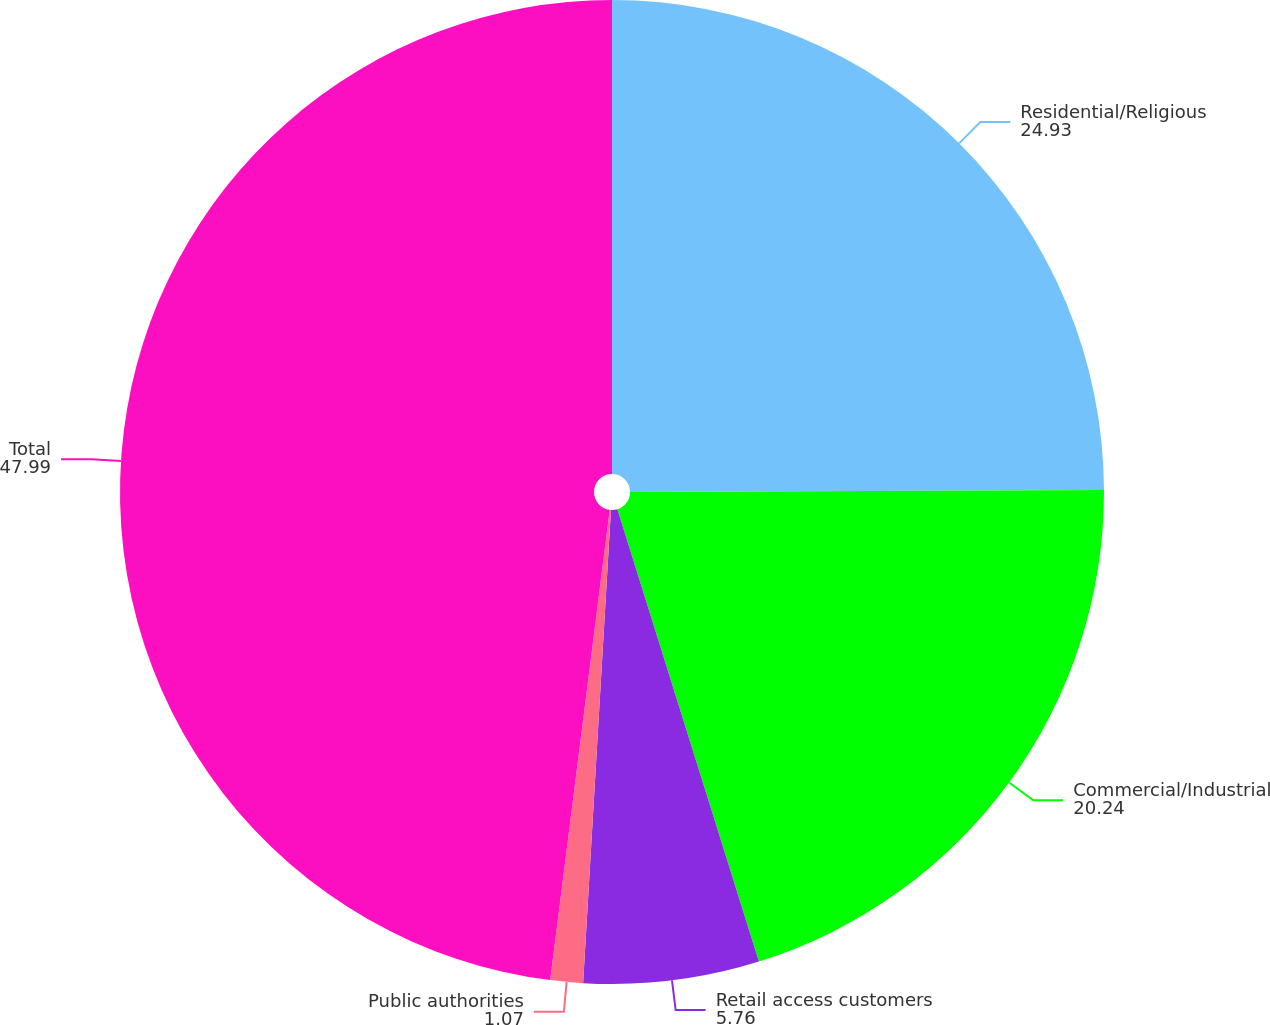Convert chart. <chart><loc_0><loc_0><loc_500><loc_500><pie_chart><fcel>Residential/Religious<fcel>Commercial/Industrial<fcel>Retail access customers<fcel>Public authorities<fcel>Total<nl><fcel>24.93%<fcel>20.24%<fcel>5.76%<fcel>1.07%<fcel>47.99%<nl></chart> 